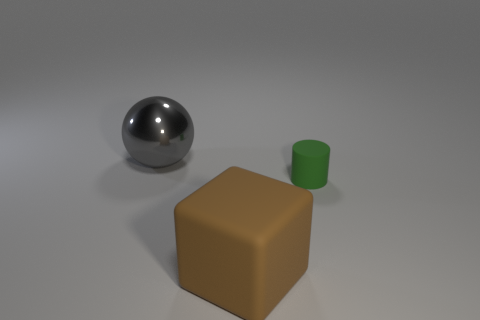Can you tell me about the lighting in this scene? The lighting in the scene is diffused and soft, casting very subtle shadows beneath the objects. This creates a calm and even illumination, highlighting the shapes and colors without causing harsh reflections or deep shadows. 